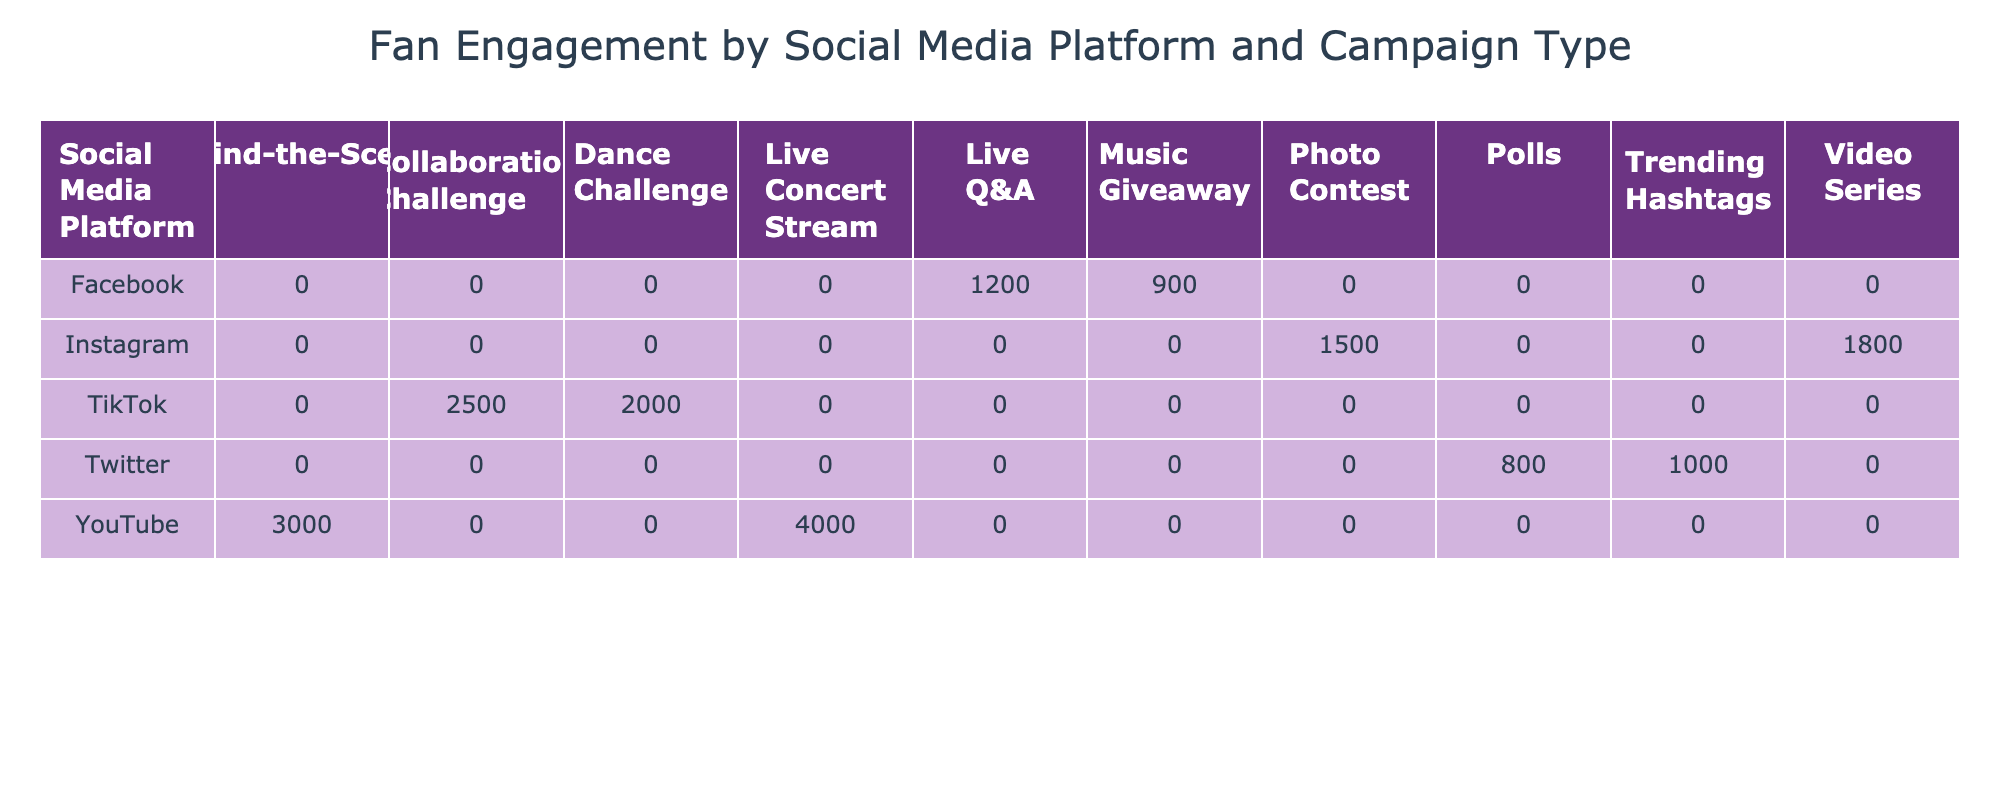What is the highest fan engagement campaign type on TikTok? The highest fan engagement campaign type on TikTok is the "Collaboration Challenge" with 2500 engagements. This is determined by comparing the fan engagement values listed under the TikTok row in the table.
Answer: 2500 Which social media platform had the lowest total fan engagement across all campaign types? To find the lowest total fan engagement, we need to sum the values for each platform. Instagram has 1500 + 1800 = 3300, Facebook has 1200 + 900 = 2100, Twitter has 800 + 1000 = 1800, TikTok has 2000 + 2500 = 4500, and YouTube has 3000 + 4000 = 7000. The total for Twitter is the lowest at 1800.
Answer: Twitter Is the total fan engagement for photo contests greater than 2000? There is only one photo contest listed under Instagram with 1500 engagements. Since 1500 is less than 2000, the statement is false.
Answer: No What is the average fan engagement for campaigns on YouTube? To determine the average for YouTube, we take the two values available: 3000 for "Behind-the-Scenes" and 4000 for "Live Concert Stream." The sum is 3000 + 4000 = 7000. Since there are 2 campaigns, the average is 7000 divided by 2, which equals 3500.
Answer: 3500 Which campaign type had a total engagement greater than 2000 across all platforms? The campaign types with engagements over 2000 are "Dance Challenge" from TikTok with 2000, "Collaboration Challenge" from TikTok with 2500, and "Live Concert Stream" from YouTube with 4000. Since the question specifies total engagement, only "Live Concert Stream" exceeds 2000.
Answer: Yes 